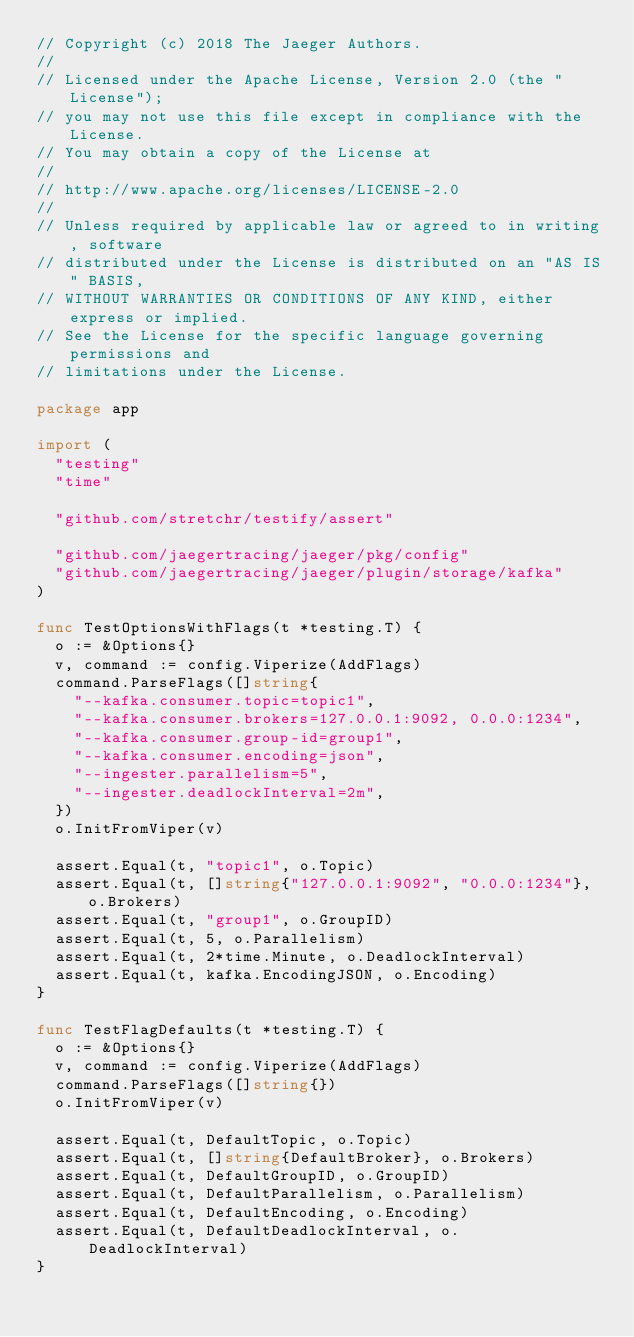<code> <loc_0><loc_0><loc_500><loc_500><_Go_>// Copyright (c) 2018 The Jaeger Authors.
//
// Licensed under the Apache License, Version 2.0 (the "License");
// you may not use this file except in compliance with the License.
// You may obtain a copy of the License at
//
// http://www.apache.org/licenses/LICENSE-2.0
//
// Unless required by applicable law or agreed to in writing, software
// distributed under the License is distributed on an "AS IS" BASIS,
// WITHOUT WARRANTIES OR CONDITIONS OF ANY KIND, either express or implied.
// See the License for the specific language governing permissions and
// limitations under the License.

package app

import (
	"testing"
	"time"

	"github.com/stretchr/testify/assert"

	"github.com/jaegertracing/jaeger/pkg/config"
	"github.com/jaegertracing/jaeger/plugin/storage/kafka"
)

func TestOptionsWithFlags(t *testing.T) {
	o := &Options{}
	v, command := config.Viperize(AddFlags)
	command.ParseFlags([]string{
		"--kafka.consumer.topic=topic1",
		"--kafka.consumer.brokers=127.0.0.1:9092, 0.0.0:1234",
		"--kafka.consumer.group-id=group1",
		"--kafka.consumer.encoding=json",
		"--ingester.parallelism=5",
		"--ingester.deadlockInterval=2m",
	})
	o.InitFromViper(v)

	assert.Equal(t, "topic1", o.Topic)
	assert.Equal(t, []string{"127.0.0.1:9092", "0.0.0:1234"}, o.Brokers)
	assert.Equal(t, "group1", o.GroupID)
	assert.Equal(t, 5, o.Parallelism)
	assert.Equal(t, 2*time.Minute, o.DeadlockInterval)
	assert.Equal(t, kafka.EncodingJSON, o.Encoding)
}

func TestFlagDefaults(t *testing.T) {
	o := &Options{}
	v, command := config.Viperize(AddFlags)
	command.ParseFlags([]string{})
	o.InitFromViper(v)

	assert.Equal(t, DefaultTopic, o.Topic)
	assert.Equal(t, []string{DefaultBroker}, o.Brokers)
	assert.Equal(t, DefaultGroupID, o.GroupID)
	assert.Equal(t, DefaultParallelism, o.Parallelism)
	assert.Equal(t, DefaultEncoding, o.Encoding)
	assert.Equal(t, DefaultDeadlockInterval, o.DeadlockInterval)
}
</code> 